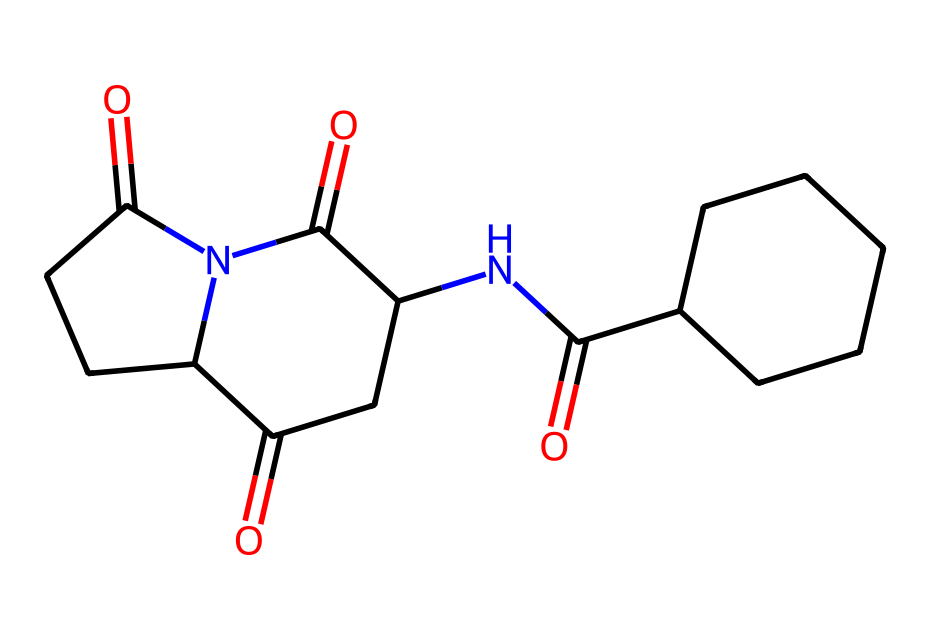What is the molecular formula of thalidomide? To find the molecular formula, count the number of each type of atom in the chemical structure represented by the SMILES. From the SMILES provided, there are 13 carbon atoms (C), 11 hydrogen atoms (H), 3 nitrogen atoms (N), and 4 oxygen atoms (O), which gives the molecular formula C13H11N3O4.
Answer: C13H11N3O4 How many chiral centers are present in thalidomide? A chiral center is typically a carbon atom that is bonded to four different groups. By analyzing the structure derived from the SMILES, there are two carbon atoms with four different substituents, indicating that there are two chiral centers in thalidomide.
Answer: 2 What is a significant lesson learned from the tragedy of thalidomide? The thalidomide case highlights the importance of thorough testing and understanding of chirality in drug development, as one enantiomer can be effective while another can cause severe birth defects.
Answer: Importance of chirality What functional groups are present in thalidomide? Identifying the functional groups involves examining the SMILES representation. Thalidomide contains carbonyls (C=O) and amides (C(=O)N), which are recognizable functional groups in its structure.
Answer: Carbonyls and amides How many rings are in the structure of thalidomide? To determine the number of rings, count the cyclical structures formed in the molecule. By analyzing the SMILES, there are two distinct rings in the thalidomide structure.
Answer: 2 Which element is primarily responsible for the unique properties of thalidomide? The nitrogen atoms play a critical role in influencing the drug's characteristics, including its biological activity and interaction with receptors, especially in the context of its amide and ring structures.
Answer: Nitrogen 